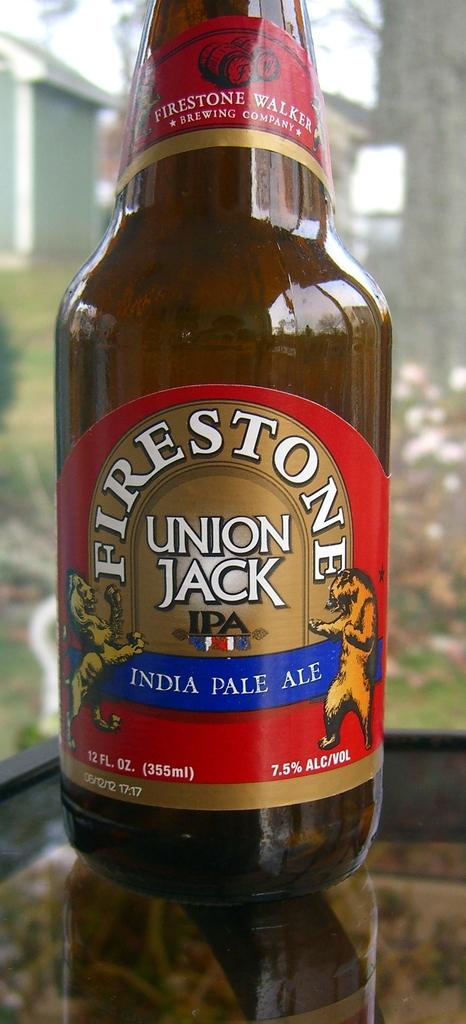<image>
Render a clear and concise summary of the photo. A bottle of Union Jack India Pale Ale has a red label with a bear on it. 